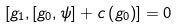Convert formula to latex. <formula><loc_0><loc_0><loc_500><loc_500>\left [ g _ { 1 } , \left [ g _ { 0 } , \psi \right ] + c \left ( g _ { 0 } \right ) \right ] = 0</formula> 